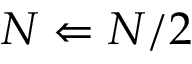<formula> <loc_0><loc_0><loc_500><loc_500>N \Leftarrow N / 2</formula> 